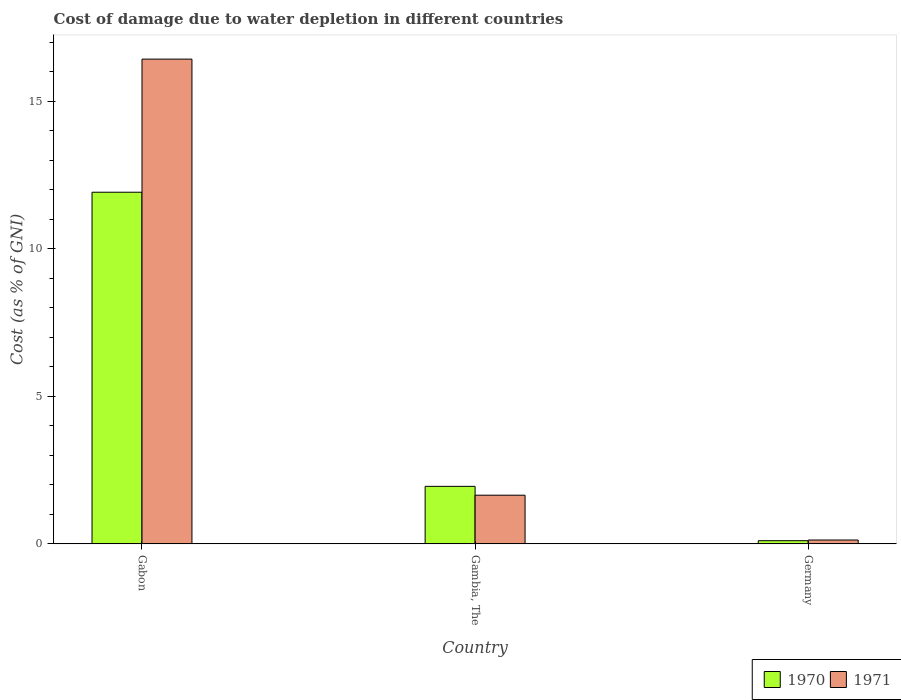How many different coloured bars are there?
Provide a succinct answer. 2. Are the number of bars per tick equal to the number of legend labels?
Ensure brevity in your answer.  Yes. How many bars are there on the 3rd tick from the left?
Ensure brevity in your answer.  2. How many bars are there on the 3rd tick from the right?
Offer a very short reply. 2. What is the label of the 2nd group of bars from the left?
Provide a succinct answer. Gambia, The. What is the cost of damage caused due to water depletion in 1971 in Germany?
Offer a terse response. 0.13. Across all countries, what is the maximum cost of damage caused due to water depletion in 1971?
Your answer should be very brief. 16.43. Across all countries, what is the minimum cost of damage caused due to water depletion in 1970?
Your answer should be very brief. 0.11. In which country was the cost of damage caused due to water depletion in 1971 maximum?
Make the answer very short. Gabon. What is the total cost of damage caused due to water depletion in 1971 in the graph?
Offer a very short reply. 18.21. What is the difference between the cost of damage caused due to water depletion in 1970 in Gabon and that in Gambia, The?
Provide a short and direct response. 9.97. What is the difference between the cost of damage caused due to water depletion in 1970 in Gabon and the cost of damage caused due to water depletion in 1971 in Gambia, The?
Your answer should be very brief. 10.27. What is the average cost of damage caused due to water depletion in 1971 per country?
Provide a succinct answer. 6.07. What is the difference between the cost of damage caused due to water depletion of/in 1970 and cost of damage caused due to water depletion of/in 1971 in Gabon?
Keep it short and to the point. -4.51. In how many countries, is the cost of damage caused due to water depletion in 1971 greater than 3 %?
Your response must be concise. 1. What is the ratio of the cost of damage caused due to water depletion in 1970 in Gambia, The to that in Germany?
Make the answer very short. 18.19. Is the cost of damage caused due to water depletion in 1971 in Gambia, The less than that in Germany?
Make the answer very short. No. Is the difference between the cost of damage caused due to water depletion in 1970 in Gambia, The and Germany greater than the difference between the cost of damage caused due to water depletion in 1971 in Gambia, The and Germany?
Give a very brief answer. Yes. What is the difference between the highest and the second highest cost of damage caused due to water depletion in 1971?
Offer a very short reply. 14.78. What is the difference between the highest and the lowest cost of damage caused due to water depletion in 1971?
Your answer should be very brief. 16.3. What does the 1st bar from the left in Gabon represents?
Offer a very short reply. 1970. How many bars are there?
Offer a very short reply. 6. Are all the bars in the graph horizontal?
Make the answer very short. No. What is the difference between two consecutive major ticks on the Y-axis?
Offer a very short reply. 5. Does the graph contain any zero values?
Offer a terse response. No. Where does the legend appear in the graph?
Offer a terse response. Bottom right. How many legend labels are there?
Offer a terse response. 2. How are the legend labels stacked?
Provide a short and direct response. Horizontal. What is the title of the graph?
Offer a terse response. Cost of damage due to water depletion in different countries. Does "1994" appear as one of the legend labels in the graph?
Give a very brief answer. No. What is the label or title of the X-axis?
Offer a terse response. Country. What is the label or title of the Y-axis?
Offer a very short reply. Cost (as % of GNI). What is the Cost (as % of GNI) of 1970 in Gabon?
Keep it short and to the point. 11.92. What is the Cost (as % of GNI) of 1971 in Gabon?
Give a very brief answer. 16.43. What is the Cost (as % of GNI) of 1970 in Gambia, The?
Make the answer very short. 1.95. What is the Cost (as % of GNI) in 1971 in Gambia, The?
Offer a very short reply. 1.65. What is the Cost (as % of GNI) of 1970 in Germany?
Give a very brief answer. 0.11. What is the Cost (as % of GNI) in 1971 in Germany?
Keep it short and to the point. 0.13. Across all countries, what is the maximum Cost (as % of GNI) of 1970?
Keep it short and to the point. 11.92. Across all countries, what is the maximum Cost (as % of GNI) in 1971?
Your answer should be compact. 16.43. Across all countries, what is the minimum Cost (as % of GNI) in 1970?
Ensure brevity in your answer.  0.11. Across all countries, what is the minimum Cost (as % of GNI) of 1971?
Your answer should be very brief. 0.13. What is the total Cost (as % of GNI) of 1970 in the graph?
Offer a very short reply. 13.98. What is the total Cost (as % of GNI) of 1971 in the graph?
Offer a terse response. 18.21. What is the difference between the Cost (as % of GNI) of 1970 in Gabon and that in Gambia, The?
Provide a succinct answer. 9.97. What is the difference between the Cost (as % of GNI) in 1971 in Gabon and that in Gambia, The?
Keep it short and to the point. 14.78. What is the difference between the Cost (as % of GNI) of 1970 in Gabon and that in Germany?
Offer a terse response. 11.81. What is the difference between the Cost (as % of GNI) of 1971 in Gabon and that in Germany?
Provide a short and direct response. 16.3. What is the difference between the Cost (as % of GNI) in 1970 in Gambia, The and that in Germany?
Offer a terse response. 1.84. What is the difference between the Cost (as % of GNI) of 1971 in Gambia, The and that in Germany?
Keep it short and to the point. 1.52. What is the difference between the Cost (as % of GNI) of 1970 in Gabon and the Cost (as % of GNI) of 1971 in Gambia, The?
Ensure brevity in your answer.  10.27. What is the difference between the Cost (as % of GNI) of 1970 in Gabon and the Cost (as % of GNI) of 1971 in Germany?
Make the answer very short. 11.79. What is the difference between the Cost (as % of GNI) in 1970 in Gambia, The and the Cost (as % of GNI) in 1971 in Germany?
Your answer should be very brief. 1.82. What is the average Cost (as % of GNI) in 1970 per country?
Make the answer very short. 4.66. What is the average Cost (as % of GNI) of 1971 per country?
Your answer should be compact. 6.07. What is the difference between the Cost (as % of GNI) in 1970 and Cost (as % of GNI) in 1971 in Gabon?
Ensure brevity in your answer.  -4.51. What is the difference between the Cost (as % of GNI) in 1970 and Cost (as % of GNI) in 1971 in Germany?
Provide a short and direct response. -0.02. What is the ratio of the Cost (as % of GNI) in 1970 in Gabon to that in Gambia, The?
Keep it short and to the point. 6.11. What is the ratio of the Cost (as % of GNI) of 1971 in Gabon to that in Gambia, The?
Ensure brevity in your answer.  9.96. What is the ratio of the Cost (as % of GNI) of 1970 in Gabon to that in Germany?
Your response must be concise. 111.24. What is the ratio of the Cost (as % of GNI) in 1971 in Gabon to that in Germany?
Offer a terse response. 125.54. What is the ratio of the Cost (as % of GNI) in 1970 in Gambia, The to that in Germany?
Your answer should be compact. 18.19. What is the ratio of the Cost (as % of GNI) of 1971 in Gambia, The to that in Germany?
Provide a succinct answer. 12.6. What is the difference between the highest and the second highest Cost (as % of GNI) in 1970?
Your response must be concise. 9.97. What is the difference between the highest and the second highest Cost (as % of GNI) in 1971?
Ensure brevity in your answer.  14.78. What is the difference between the highest and the lowest Cost (as % of GNI) in 1970?
Ensure brevity in your answer.  11.81. What is the difference between the highest and the lowest Cost (as % of GNI) in 1971?
Ensure brevity in your answer.  16.3. 